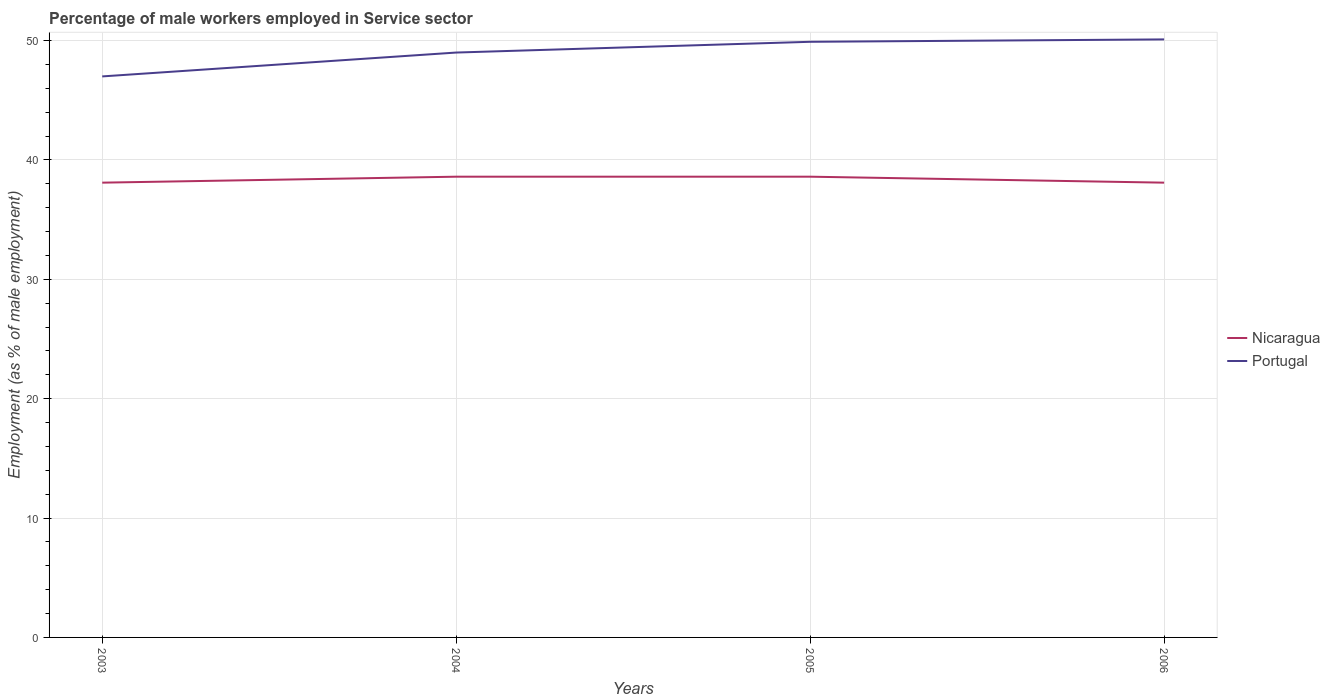How many different coloured lines are there?
Your answer should be very brief. 2. Does the line corresponding to Portugal intersect with the line corresponding to Nicaragua?
Keep it short and to the point. No. Is the number of lines equal to the number of legend labels?
Offer a terse response. Yes. Across all years, what is the maximum percentage of male workers employed in Service sector in Nicaragua?
Your answer should be compact. 38.1. In which year was the percentage of male workers employed in Service sector in Portugal maximum?
Give a very brief answer. 2003. What is the total percentage of male workers employed in Service sector in Nicaragua in the graph?
Make the answer very short. 0.5. What is the difference between the highest and the second highest percentage of male workers employed in Service sector in Portugal?
Provide a succinct answer. 3.1. How many years are there in the graph?
Ensure brevity in your answer.  4. What is the difference between two consecutive major ticks on the Y-axis?
Keep it short and to the point. 10. Does the graph contain any zero values?
Ensure brevity in your answer.  No. How many legend labels are there?
Give a very brief answer. 2. How are the legend labels stacked?
Give a very brief answer. Vertical. What is the title of the graph?
Provide a short and direct response. Percentage of male workers employed in Service sector. Does "Morocco" appear as one of the legend labels in the graph?
Offer a very short reply. No. What is the label or title of the Y-axis?
Offer a very short reply. Employment (as % of male employment). What is the Employment (as % of male employment) in Nicaragua in 2003?
Provide a short and direct response. 38.1. What is the Employment (as % of male employment) in Portugal in 2003?
Give a very brief answer. 47. What is the Employment (as % of male employment) in Nicaragua in 2004?
Make the answer very short. 38.6. What is the Employment (as % of male employment) in Portugal in 2004?
Give a very brief answer. 49. What is the Employment (as % of male employment) in Nicaragua in 2005?
Provide a short and direct response. 38.6. What is the Employment (as % of male employment) in Portugal in 2005?
Your answer should be compact. 49.9. What is the Employment (as % of male employment) of Nicaragua in 2006?
Your answer should be very brief. 38.1. What is the Employment (as % of male employment) in Portugal in 2006?
Ensure brevity in your answer.  50.1. Across all years, what is the maximum Employment (as % of male employment) in Nicaragua?
Make the answer very short. 38.6. Across all years, what is the maximum Employment (as % of male employment) of Portugal?
Give a very brief answer. 50.1. Across all years, what is the minimum Employment (as % of male employment) in Nicaragua?
Keep it short and to the point. 38.1. What is the total Employment (as % of male employment) in Nicaragua in the graph?
Offer a very short reply. 153.4. What is the total Employment (as % of male employment) in Portugal in the graph?
Make the answer very short. 196. What is the difference between the Employment (as % of male employment) of Portugal in 2003 and that in 2004?
Keep it short and to the point. -2. What is the difference between the Employment (as % of male employment) of Portugal in 2003 and that in 2005?
Provide a succinct answer. -2.9. What is the difference between the Employment (as % of male employment) of Nicaragua in 2003 and that in 2006?
Your answer should be very brief. 0. What is the difference between the Employment (as % of male employment) of Nicaragua in 2004 and that in 2006?
Your answer should be very brief. 0.5. What is the difference between the Employment (as % of male employment) in Portugal in 2004 and that in 2006?
Your answer should be compact. -1.1. What is the difference between the Employment (as % of male employment) in Nicaragua in 2005 and that in 2006?
Your answer should be very brief. 0.5. What is the difference between the Employment (as % of male employment) of Nicaragua in 2003 and the Employment (as % of male employment) of Portugal in 2004?
Your response must be concise. -10.9. What is the difference between the Employment (as % of male employment) in Nicaragua in 2003 and the Employment (as % of male employment) in Portugal in 2005?
Keep it short and to the point. -11.8. What is the difference between the Employment (as % of male employment) in Nicaragua in 2003 and the Employment (as % of male employment) in Portugal in 2006?
Give a very brief answer. -12. What is the difference between the Employment (as % of male employment) of Nicaragua in 2004 and the Employment (as % of male employment) of Portugal in 2006?
Provide a short and direct response. -11.5. What is the average Employment (as % of male employment) in Nicaragua per year?
Your answer should be compact. 38.35. In the year 2005, what is the difference between the Employment (as % of male employment) in Nicaragua and Employment (as % of male employment) in Portugal?
Make the answer very short. -11.3. What is the ratio of the Employment (as % of male employment) of Portugal in 2003 to that in 2004?
Ensure brevity in your answer.  0.96. What is the ratio of the Employment (as % of male employment) in Portugal in 2003 to that in 2005?
Offer a very short reply. 0.94. What is the ratio of the Employment (as % of male employment) in Portugal in 2003 to that in 2006?
Provide a short and direct response. 0.94. What is the ratio of the Employment (as % of male employment) of Nicaragua in 2004 to that in 2005?
Your response must be concise. 1. What is the ratio of the Employment (as % of male employment) of Portugal in 2004 to that in 2005?
Make the answer very short. 0.98. What is the ratio of the Employment (as % of male employment) in Nicaragua in 2004 to that in 2006?
Make the answer very short. 1.01. What is the ratio of the Employment (as % of male employment) of Portugal in 2004 to that in 2006?
Make the answer very short. 0.98. What is the ratio of the Employment (as % of male employment) in Nicaragua in 2005 to that in 2006?
Your response must be concise. 1.01. What is the difference between the highest and the second highest Employment (as % of male employment) of Portugal?
Provide a short and direct response. 0.2. What is the difference between the highest and the lowest Employment (as % of male employment) of Nicaragua?
Your answer should be compact. 0.5. 